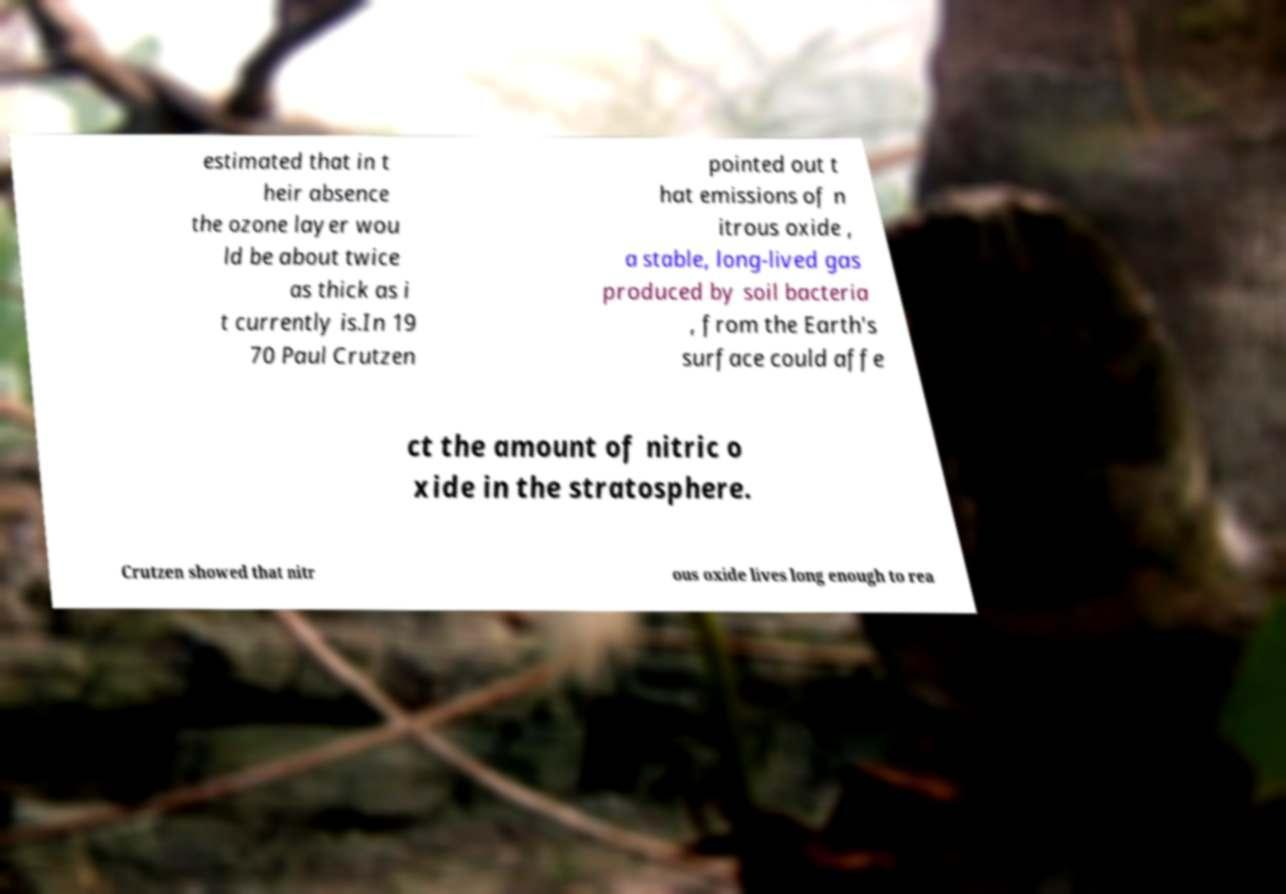Could you assist in decoding the text presented in this image and type it out clearly? estimated that in t heir absence the ozone layer wou ld be about twice as thick as i t currently is.In 19 70 Paul Crutzen pointed out t hat emissions of n itrous oxide , a stable, long-lived gas produced by soil bacteria , from the Earth's surface could affe ct the amount of nitric o xide in the stratosphere. Crutzen showed that nitr ous oxide lives long enough to rea 